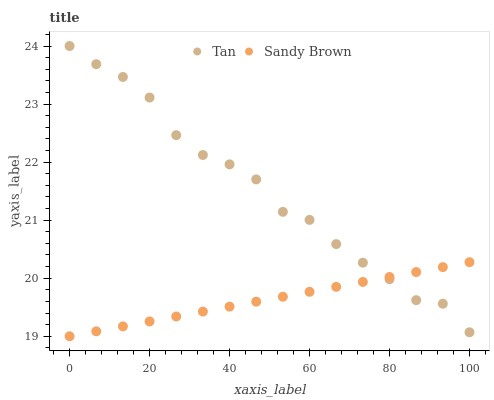Does Sandy Brown have the minimum area under the curve?
Answer yes or no. Yes. Does Tan have the maximum area under the curve?
Answer yes or no. Yes. Does Sandy Brown have the maximum area under the curve?
Answer yes or no. No. Is Sandy Brown the smoothest?
Answer yes or no. Yes. Is Tan the roughest?
Answer yes or no. Yes. Is Sandy Brown the roughest?
Answer yes or no. No. Does Sandy Brown have the lowest value?
Answer yes or no. Yes. Does Tan have the highest value?
Answer yes or no. Yes. Does Sandy Brown have the highest value?
Answer yes or no. No. Does Tan intersect Sandy Brown?
Answer yes or no. Yes. Is Tan less than Sandy Brown?
Answer yes or no. No. Is Tan greater than Sandy Brown?
Answer yes or no. No. 